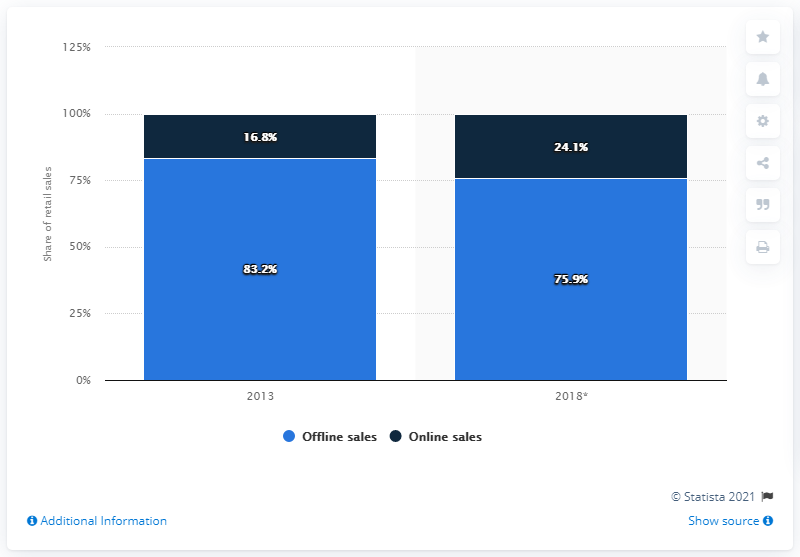Outline some significant characteristics in this image. By 2018, it is predicted that there will be a significant increase in online sales of sports and leisure equipment. Specifically, this increase is expected to be 24.1%. In 2013, online sales accounted for 16.8% of retail sales of sports and leisure equipment. 